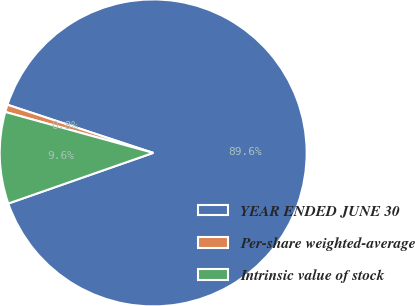Convert chart. <chart><loc_0><loc_0><loc_500><loc_500><pie_chart><fcel>YEAR ENDED JUNE 30<fcel>Per-share weighted-average<fcel>Intrinsic value of stock<nl><fcel>89.57%<fcel>0.78%<fcel>9.65%<nl></chart> 